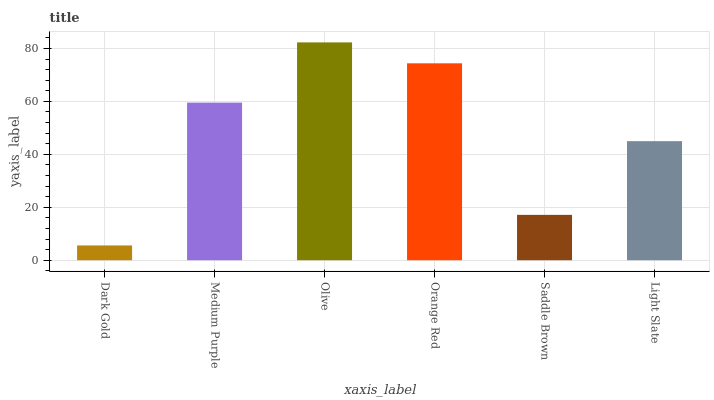Is Dark Gold the minimum?
Answer yes or no. Yes. Is Olive the maximum?
Answer yes or no. Yes. Is Medium Purple the minimum?
Answer yes or no. No. Is Medium Purple the maximum?
Answer yes or no. No. Is Medium Purple greater than Dark Gold?
Answer yes or no. Yes. Is Dark Gold less than Medium Purple?
Answer yes or no. Yes. Is Dark Gold greater than Medium Purple?
Answer yes or no. No. Is Medium Purple less than Dark Gold?
Answer yes or no. No. Is Medium Purple the high median?
Answer yes or no. Yes. Is Light Slate the low median?
Answer yes or no. Yes. Is Orange Red the high median?
Answer yes or no. No. Is Dark Gold the low median?
Answer yes or no. No. 